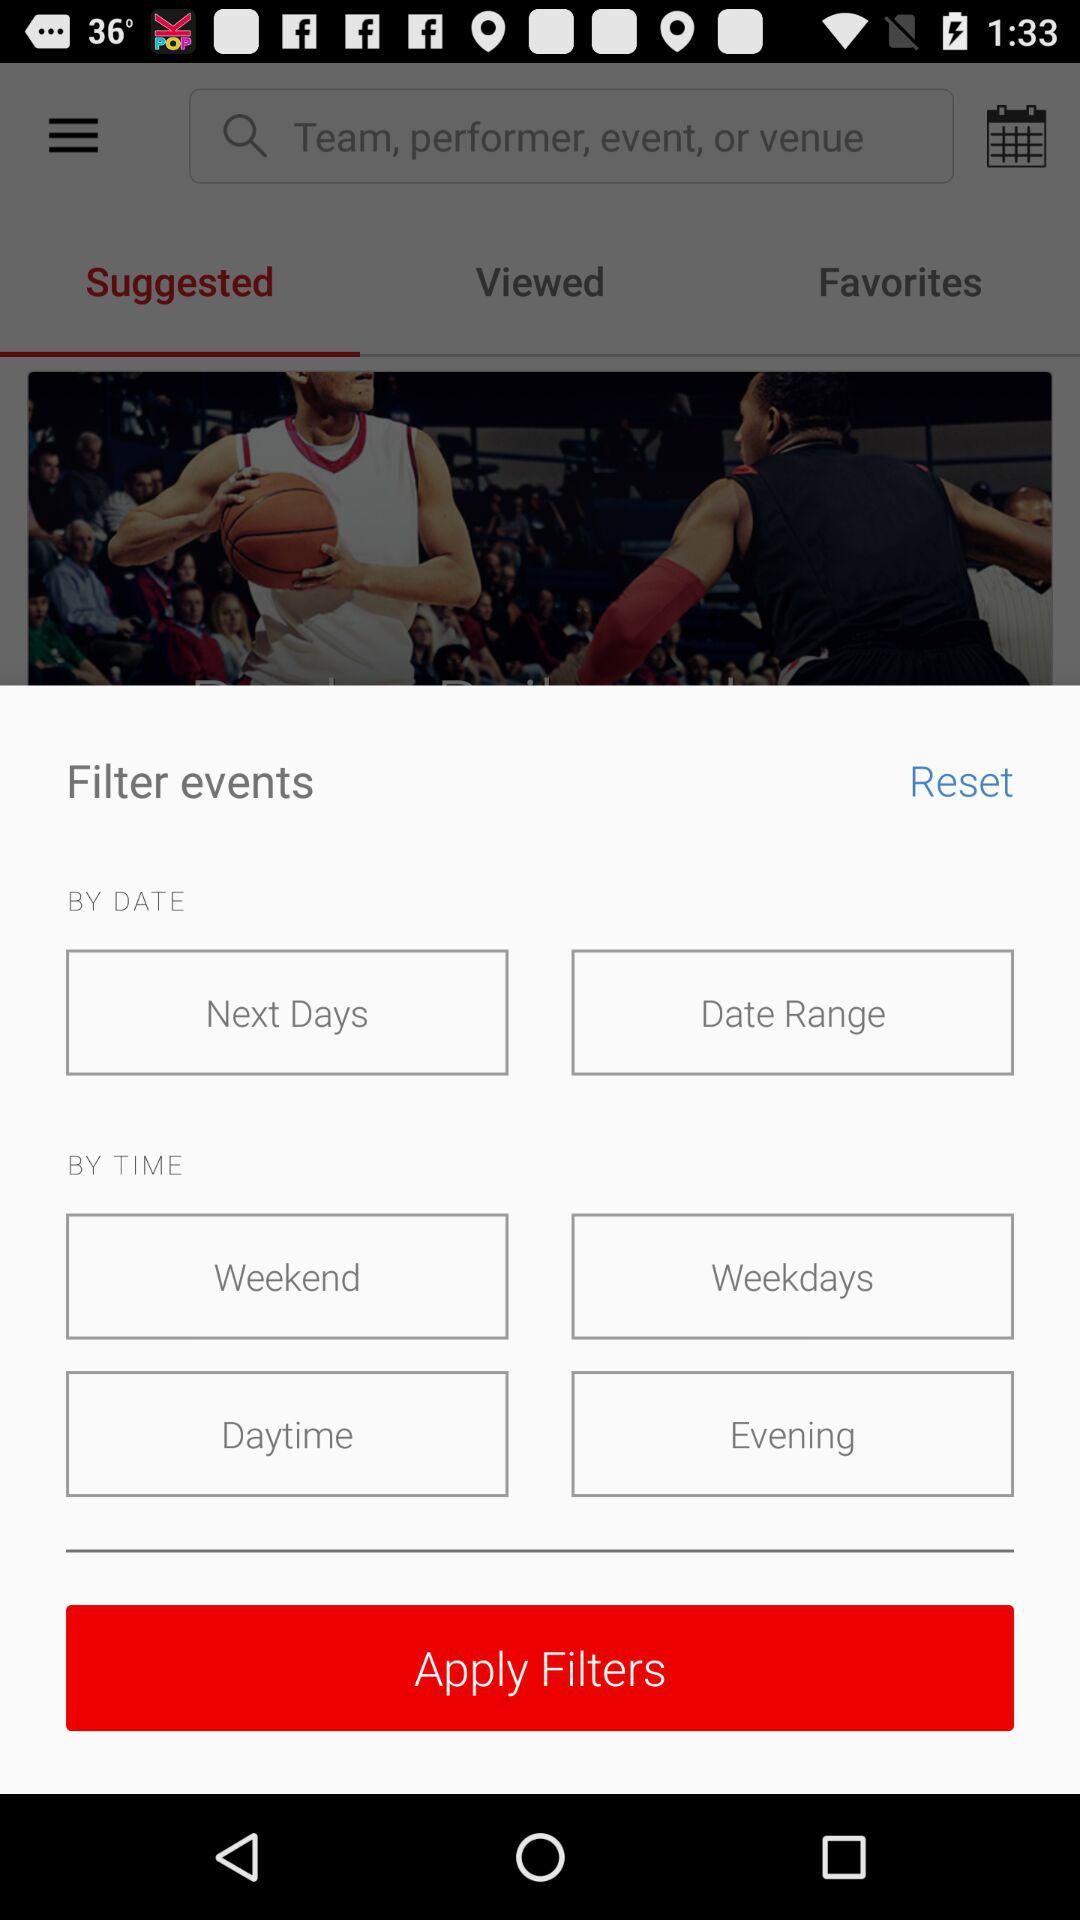How many time filters are there?
Answer the question using a single word or phrase. 4 